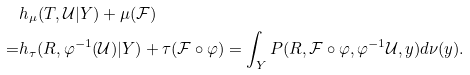Convert formula to latex. <formula><loc_0><loc_0><loc_500><loc_500>& h _ { \mu } ( T , \mathcal { U } | Y ) + \mu ( \mathcal { F } ) \\ = & h _ { \tau } ( R , \varphi ^ { - 1 } ( \mathcal { U } ) | Y ) + \tau ( \mathcal { F } \circ \varphi ) = \int _ { Y } P ( R , \mathcal { F } \circ \varphi , \varphi ^ { - 1 } \mathcal { U } , y ) d \nu ( y ) .</formula> 